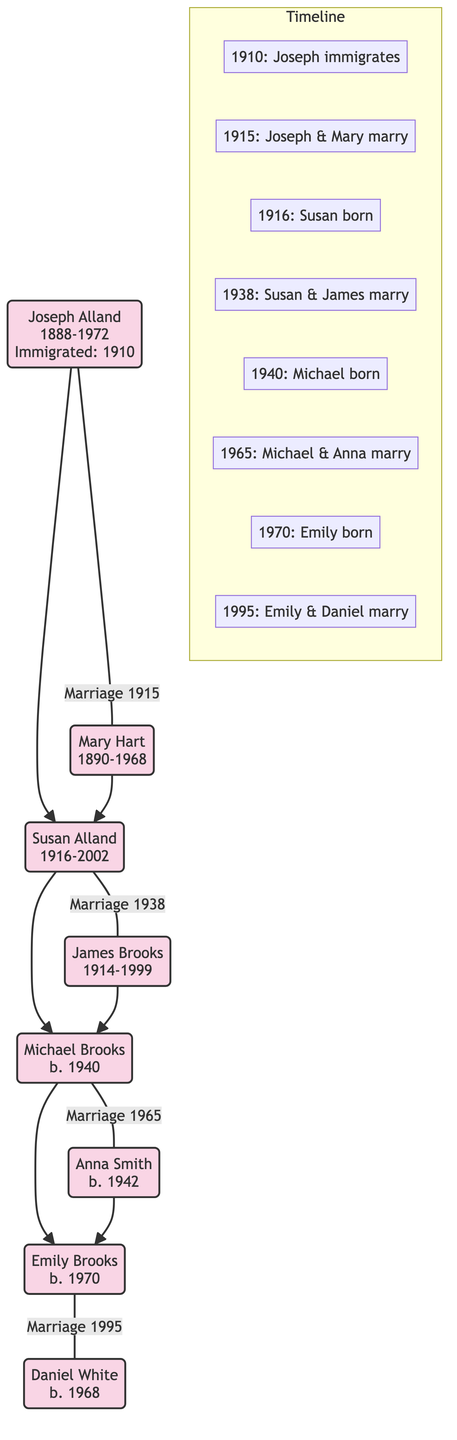What year did Joseph Alland immigrate? The diagram indicates under the "Timeline" section that Joseph immigrated in 1910.
Answer: 1910 Who is Joseph Alland's spouse? According to the diagram, Joseph Alland's spouse is Mary Hart, who is directly connected to him with a marriage link.
Answer: Mary Hart How many children did Joseph Alland have? From the diagram, we see that Joseph Alland has one child, Susan Alland, who is the only descendant shown under him.
Answer: 1 In what year did Susan Alland marry James Brooks? The diagram shows that the marriage of Susan Alland and James Brooks occurred in the year 1938, which is detailed in the "Timeline" section.
Answer: 1938 Who was born in 1970? The diagram states that Emily Brooks was born in 1970, as evidenced by her placement and the annotation in the timeline.
Answer: Emily Brooks What is the relationship between Michael Brooks and Emily Brooks? The diagram shows that Michael Brooks is Emily Brooks' father, as he is connected to her as a child in the family tree structure.
Answer: Father How many marriages are represented in the diagram? By analyzing the diagram, we find a total of four marriages: Joseph & Mary, Susan & James, Michael & Anna, and Emily & Daniel, thus totaling four connections.
Answer: 4 What year was Emily Brooks married? The diagram indicates that Emily Brooks was married in 1995, which is mentioned in the timeline section with a linked annotation.
Answer: 1995 Who is the child of Michael Brooks and Anna Smith? The diagram shows that Michael Brooks and Anna Smith's child is Emily Brooks, who is directly connected as their daughter beneath them.
Answer: Emily Brooks 